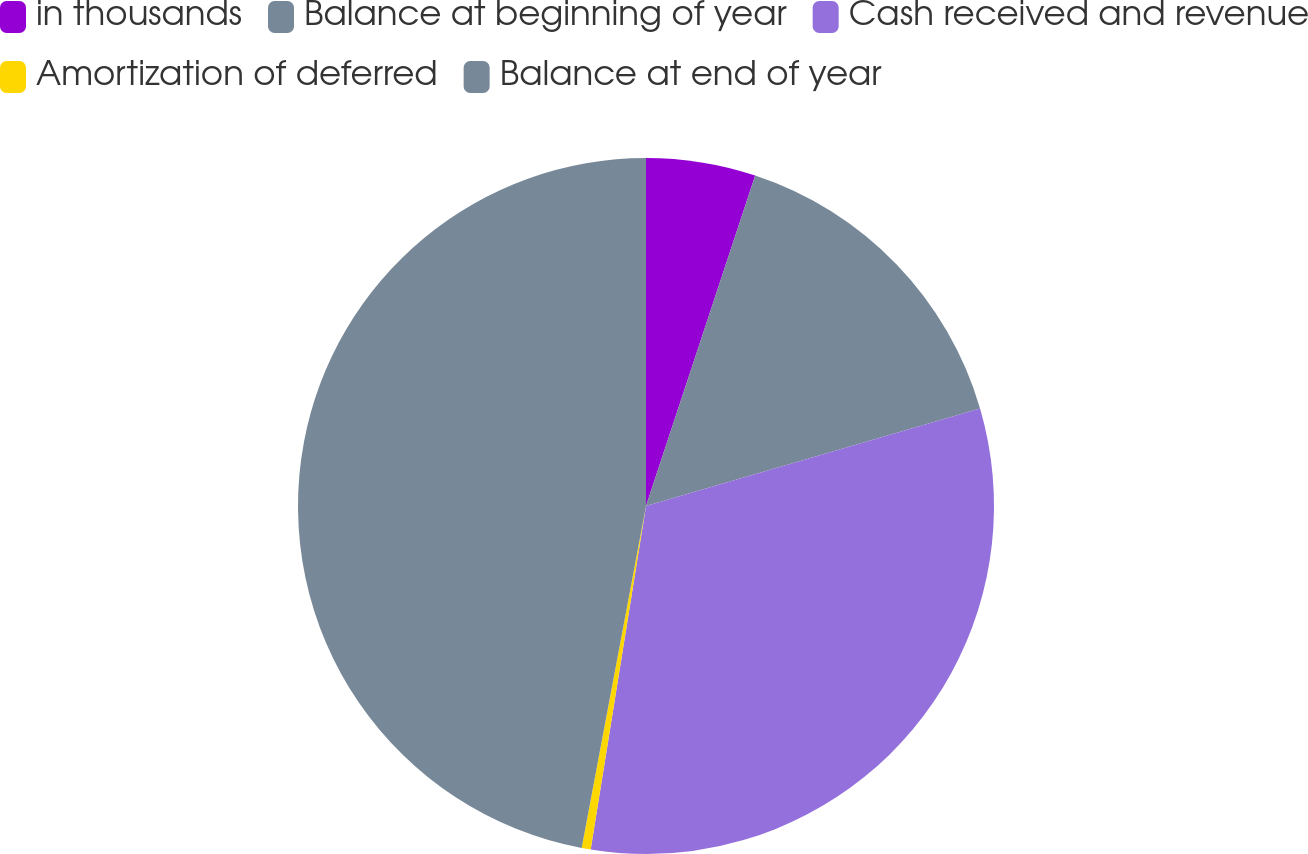Convert chart to OTSL. <chart><loc_0><loc_0><loc_500><loc_500><pie_chart><fcel>in thousands<fcel>Balance at beginning of year<fcel>Cash received and revenue<fcel>Amortization of deferred<fcel>Balance at end of year<nl><fcel>5.08%<fcel>15.4%<fcel>32.06%<fcel>0.42%<fcel>47.04%<nl></chart> 